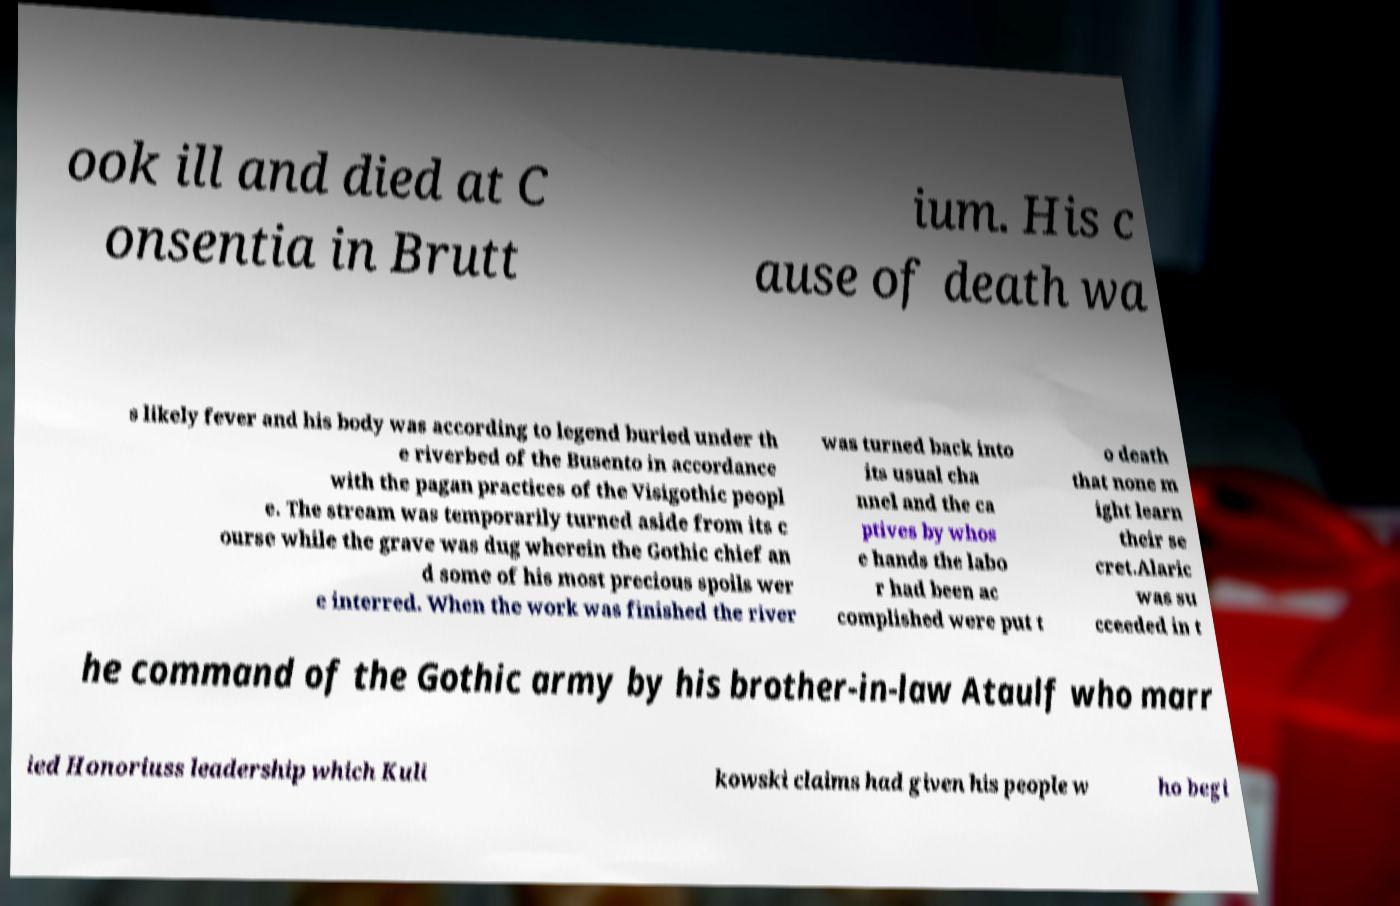There's text embedded in this image that I need extracted. Can you transcribe it verbatim? ook ill and died at C onsentia in Brutt ium. His c ause of death wa s likely fever and his body was according to legend buried under th e riverbed of the Busento in accordance with the pagan practices of the Visigothic peopl e. The stream was temporarily turned aside from its c ourse while the grave was dug wherein the Gothic chief an d some of his most precious spoils wer e interred. When the work was finished the river was turned back into its usual cha nnel and the ca ptives by whos e hands the labo r had been ac complished were put t o death that none m ight learn their se cret.Alaric was su cceeded in t he command of the Gothic army by his brother-in-law Ataulf who marr ied Honoriuss leadership which Kuli kowski claims had given his people w ho begi 